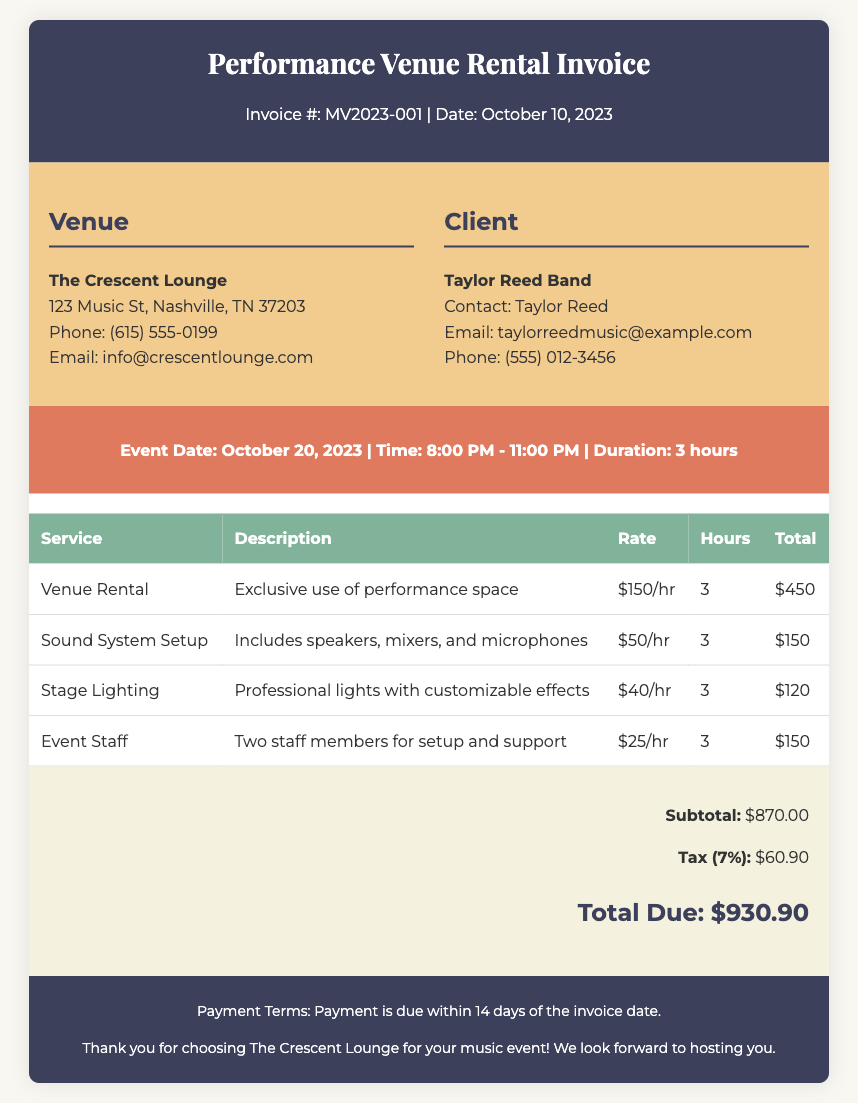What is the invoice number? The invoice number is listed at the top of the document, indicating the unique identifier for this invoice.
Answer: MV2023-001 What is the venue name? The venue name is prominently displayed in the venue information section of the document.
Answer: The Crescent Lounge What is the total amount due? The total amount due is calculated by adding the subtotal and tax, which is shown at the bottom of the invoice.
Answer: $930.90 How many hours was the venue rented? The number of hours rented for the venue is indicated in the performance details section.
Answer: 3 What is the tax rate applied to the subtotal? The tax rate is mentioned when calculating the tax amount in the summary section of the document.
Answer: 7% Which service has the highest hourly rate? The service with the highest hourly rate can be determined by comparing the rates listed for each service in the table.
Answer: Venue Rental What is the duration of the event? The duration of the event is specified in the performance details section, detailing how long the event will last.
Answer: 3 hours What are the payment terms? The payment terms are stated in the footer of the invoice, outlining the deadline for payment.
Answer: Payment is due within 14 days of the invoice date How many staff members are included in the event staff service? The number of staff members provided for the event can be found in the description of the event staff service listed in the table.
Answer: Two staff members 